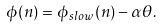Convert formula to latex. <formula><loc_0><loc_0><loc_500><loc_500>\phi ( n ) = \phi _ { s l o w } ( n ) - \alpha \theta .</formula> 